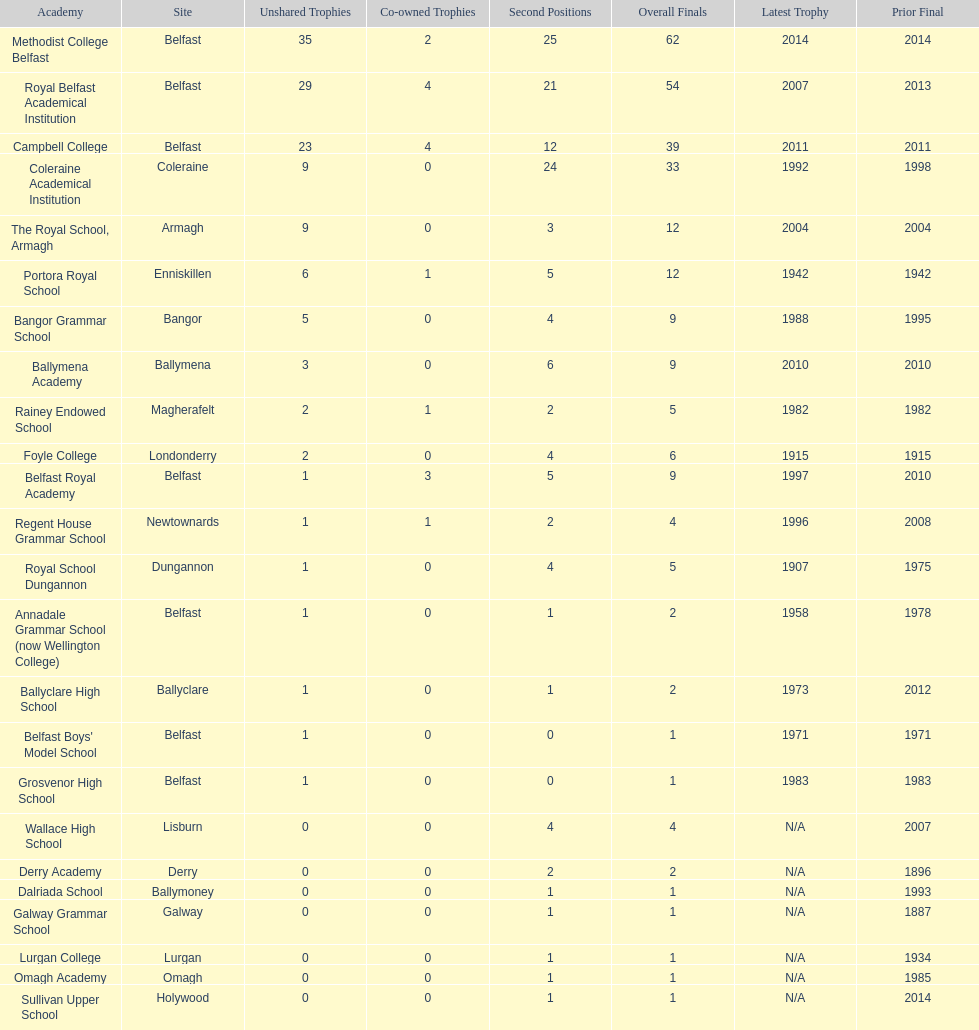How many schools had above 5 outright titles? 6. 